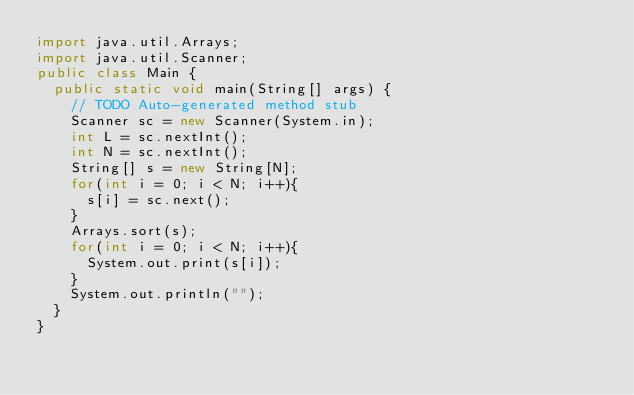<code> <loc_0><loc_0><loc_500><loc_500><_Java_>import java.util.Arrays;
import java.util.Scanner;
public class Main {
	public static void main(String[] args) {
		// TODO Auto-generated method stub
		Scanner sc = new Scanner(System.in);
		int L = sc.nextInt();
		int N = sc.nextInt();
		String[] s = new String[N];
		for(int i = 0; i < N; i++){
			s[i] = sc.next();
		}
		Arrays.sort(s);
		for(int i = 0; i < N; i++){
			System.out.print(s[i]);
		}
		System.out.println("");
	}
}</code> 